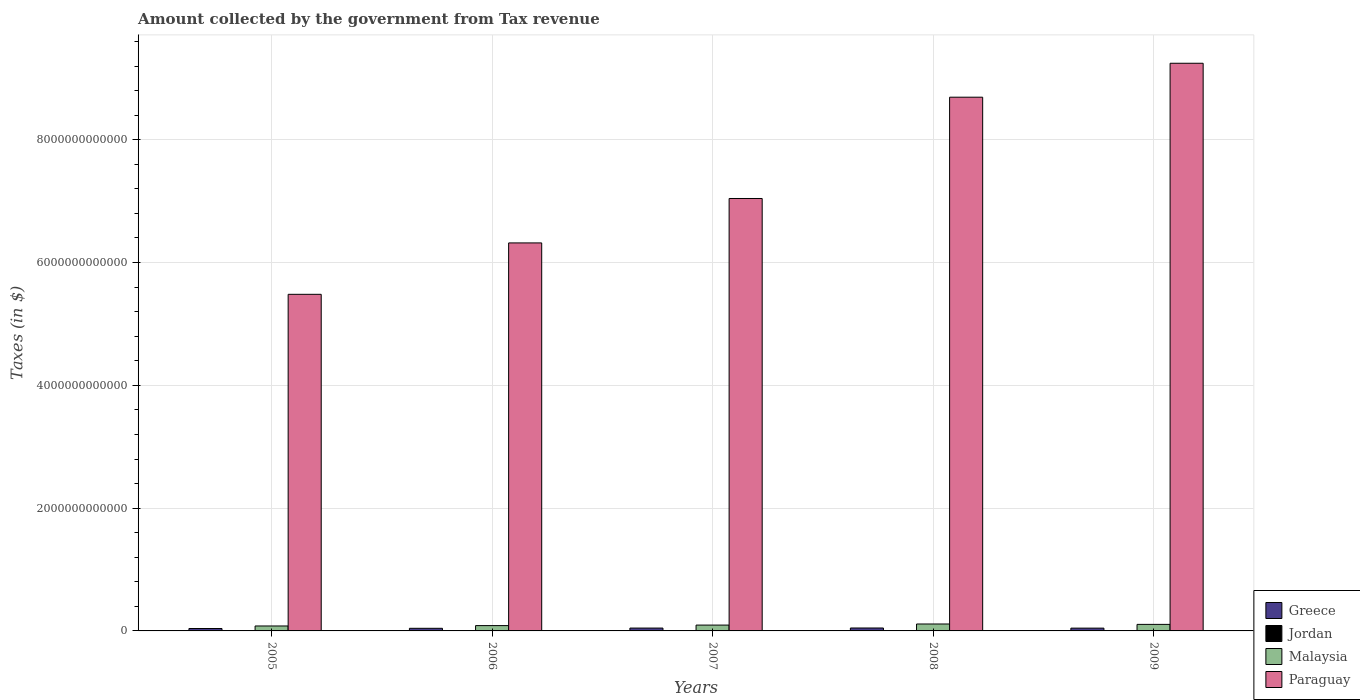How many different coloured bars are there?
Ensure brevity in your answer.  4. How many groups of bars are there?
Keep it short and to the point. 5. Are the number of bars on each tick of the X-axis equal?
Offer a terse response. Yes. How many bars are there on the 4th tick from the left?
Provide a short and direct response. 4. In how many cases, is the number of bars for a given year not equal to the number of legend labels?
Your response must be concise. 0. What is the amount collected by the government from tax revenue in Jordan in 2009?
Offer a very short reply. 2.88e+09. Across all years, what is the maximum amount collected by the government from tax revenue in Greece?
Your answer should be very brief. 4.77e+1. Across all years, what is the minimum amount collected by the government from tax revenue in Paraguay?
Your answer should be very brief. 5.48e+12. What is the total amount collected by the government from tax revenue in Malaysia in the graph?
Your answer should be compact. 4.82e+11. What is the difference between the amount collected by the government from tax revenue in Malaysia in 2005 and that in 2007?
Your response must be concise. -1.46e+1. What is the difference between the amount collected by the government from tax revenue in Jordan in 2007 and the amount collected by the government from tax revenue in Greece in 2005?
Your answer should be compact. -3.63e+1. What is the average amount collected by the government from tax revenue in Jordan per year?
Ensure brevity in your answer.  2.69e+09. In the year 2009, what is the difference between the amount collected by the government from tax revenue in Paraguay and amount collected by the government from tax revenue in Jordan?
Give a very brief answer. 9.24e+12. What is the ratio of the amount collected by the government from tax revenue in Paraguay in 2005 to that in 2006?
Your answer should be very brief. 0.87. Is the amount collected by the government from tax revenue in Paraguay in 2006 less than that in 2009?
Offer a very short reply. Yes. Is the difference between the amount collected by the government from tax revenue in Paraguay in 2005 and 2007 greater than the difference between the amount collected by the government from tax revenue in Jordan in 2005 and 2007?
Offer a terse response. No. What is the difference between the highest and the second highest amount collected by the government from tax revenue in Paraguay?
Your answer should be very brief. 5.53e+11. What is the difference between the highest and the lowest amount collected by the government from tax revenue in Greece?
Offer a very short reply. 8.40e+09. In how many years, is the amount collected by the government from tax revenue in Greece greater than the average amount collected by the government from tax revenue in Greece taken over all years?
Provide a succinct answer. 3. Is the sum of the amount collected by the government from tax revenue in Malaysia in 2005 and 2008 greater than the maximum amount collected by the government from tax revenue in Jordan across all years?
Make the answer very short. Yes. Is it the case that in every year, the sum of the amount collected by the government from tax revenue in Jordan and amount collected by the government from tax revenue in Paraguay is greater than the sum of amount collected by the government from tax revenue in Malaysia and amount collected by the government from tax revenue in Greece?
Give a very brief answer. Yes. What does the 3rd bar from the left in 2008 represents?
Give a very brief answer. Malaysia. What does the 1st bar from the right in 2009 represents?
Keep it short and to the point. Paraguay. Is it the case that in every year, the sum of the amount collected by the government from tax revenue in Malaysia and amount collected by the government from tax revenue in Jordan is greater than the amount collected by the government from tax revenue in Paraguay?
Your response must be concise. No. How many bars are there?
Give a very brief answer. 20. What is the difference between two consecutive major ticks on the Y-axis?
Provide a short and direct response. 2.00e+12. Where does the legend appear in the graph?
Make the answer very short. Bottom right. How many legend labels are there?
Give a very brief answer. 4. How are the legend labels stacked?
Give a very brief answer. Vertical. What is the title of the graph?
Give a very brief answer. Amount collected by the government from Tax revenue. What is the label or title of the Y-axis?
Your answer should be compact. Taxes (in $). What is the Taxes (in $) in Greece in 2005?
Provide a short and direct response. 3.93e+1. What is the Taxes (in $) of Jordan in 2005?
Make the answer very short. 2.18e+09. What is the Taxes (in $) in Malaysia in 2005?
Provide a short and direct response. 8.06e+1. What is the Taxes (in $) in Paraguay in 2005?
Offer a very short reply. 5.48e+12. What is the Taxes (in $) in Greece in 2006?
Offer a terse response. 4.27e+1. What is the Taxes (in $) of Jordan in 2006?
Your answer should be compact. 2.62e+09. What is the Taxes (in $) in Malaysia in 2006?
Your answer should be very brief. 8.66e+1. What is the Taxes (in $) in Paraguay in 2006?
Your response must be concise. 6.32e+12. What is the Taxes (in $) of Greece in 2007?
Provide a succinct answer. 4.64e+1. What is the Taxes (in $) in Jordan in 2007?
Give a very brief answer. 3.00e+09. What is the Taxes (in $) in Malaysia in 2007?
Your answer should be very brief. 9.52e+1. What is the Taxes (in $) of Paraguay in 2007?
Give a very brief answer. 7.04e+12. What is the Taxes (in $) of Greece in 2008?
Provide a succinct answer. 4.77e+1. What is the Taxes (in $) of Jordan in 2008?
Offer a terse response. 2.76e+09. What is the Taxes (in $) of Malaysia in 2008?
Provide a succinct answer. 1.13e+11. What is the Taxes (in $) of Paraguay in 2008?
Your answer should be very brief. 8.69e+12. What is the Taxes (in $) of Greece in 2009?
Ensure brevity in your answer.  4.53e+1. What is the Taxes (in $) of Jordan in 2009?
Provide a succinct answer. 2.88e+09. What is the Taxes (in $) of Malaysia in 2009?
Keep it short and to the point. 1.07e+11. What is the Taxes (in $) of Paraguay in 2009?
Your answer should be very brief. 9.25e+12. Across all years, what is the maximum Taxes (in $) of Greece?
Give a very brief answer. 4.77e+1. Across all years, what is the maximum Taxes (in $) in Jordan?
Give a very brief answer. 3.00e+09. Across all years, what is the maximum Taxes (in $) of Malaysia?
Your answer should be compact. 1.13e+11. Across all years, what is the maximum Taxes (in $) of Paraguay?
Your answer should be very brief. 9.25e+12. Across all years, what is the minimum Taxes (in $) in Greece?
Provide a short and direct response. 3.93e+1. Across all years, what is the minimum Taxes (in $) in Jordan?
Give a very brief answer. 2.18e+09. Across all years, what is the minimum Taxes (in $) of Malaysia?
Keep it short and to the point. 8.06e+1. Across all years, what is the minimum Taxes (in $) of Paraguay?
Ensure brevity in your answer.  5.48e+12. What is the total Taxes (in $) in Greece in the graph?
Offer a terse response. 2.21e+11. What is the total Taxes (in $) in Jordan in the graph?
Ensure brevity in your answer.  1.34e+1. What is the total Taxes (in $) of Malaysia in the graph?
Make the answer very short. 4.82e+11. What is the total Taxes (in $) in Paraguay in the graph?
Provide a succinct answer. 3.68e+13. What is the difference between the Taxes (in $) of Greece in 2005 and that in 2006?
Your answer should be compact. -3.47e+09. What is the difference between the Taxes (in $) of Jordan in 2005 and that in 2006?
Offer a terse response. -4.42e+08. What is the difference between the Taxes (in $) of Malaysia in 2005 and that in 2006?
Make the answer very short. -6.04e+09. What is the difference between the Taxes (in $) in Paraguay in 2005 and that in 2006?
Provide a succinct answer. -8.37e+11. What is the difference between the Taxes (in $) in Greece in 2005 and that in 2007?
Provide a short and direct response. -7.13e+09. What is the difference between the Taxes (in $) of Jordan in 2005 and that in 2007?
Your response must be concise. -8.16e+08. What is the difference between the Taxes (in $) in Malaysia in 2005 and that in 2007?
Make the answer very short. -1.46e+1. What is the difference between the Taxes (in $) in Paraguay in 2005 and that in 2007?
Your answer should be compact. -1.56e+12. What is the difference between the Taxes (in $) in Greece in 2005 and that in 2008?
Make the answer very short. -8.40e+09. What is the difference between the Taxes (in $) in Jordan in 2005 and that in 2008?
Ensure brevity in your answer.  -5.79e+08. What is the difference between the Taxes (in $) in Malaysia in 2005 and that in 2008?
Your response must be concise. -3.23e+1. What is the difference between the Taxes (in $) of Paraguay in 2005 and that in 2008?
Give a very brief answer. -3.21e+12. What is the difference between the Taxes (in $) of Greece in 2005 and that in 2009?
Make the answer very short. -6.06e+09. What is the difference between the Taxes (in $) in Jordan in 2005 and that in 2009?
Your answer should be compact. -7.01e+08. What is the difference between the Taxes (in $) of Malaysia in 2005 and that in 2009?
Provide a succinct answer. -2.59e+1. What is the difference between the Taxes (in $) of Paraguay in 2005 and that in 2009?
Your answer should be very brief. -3.76e+12. What is the difference between the Taxes (in $) in Greece in 2006 and that in 2007?
Provide a short and direct response. -3.66e+09. What is the difference between the Taxes (in $) in Jordan in 2006 and that in 2007?
Give a very brief answer. -3.74e+08. What is the difference between the Taxes (in $) in Malaysia in 2006 and that in 2007?
Make the answer very short. -8.54e+09. What is the difference between the Taxes (in $) in Paraguay in 2006 and that in 2007?
Offer a very short reply. -7.24e+11. What is the difference between the Taxes (in $) in Greece in 2006 and that in 2008?
Offer a very short reply. -4.93e+09. What is the difference between the Taxes (in $) of Jordan in 2006 and that in 2008?
Make the answer very short. -1.37e+08. What is the difference between the Taxes (in $) of Malaysia in 2006 and that in 2008?
Offer a terse response. -2.63e+1. What is the difference between the Taxes (in $) of Paraguay in 2006 and that in 2008?
Offer a terse response. -2.37e+12. What is the difference between the Taxes (in $) of Greece in 2006 and that in 2009?
Make the answer very short. -2.59e+09. What is the difference between the Taxes (in $) of Jordan in 2006 and that in 2009?
Give a very brief answer. -2.59e+08. What is the difference between the Taxes (in $) of Malaysia in 2006 and that in 2009?
Your answer should be very brief. -1.99e+1. What is the difference between the Taxes (in $) of Paraguay in 2006 and that in 2009?
Your answer should be compact. -2.93e+12. What is the difference between the Taxes (in $) in Greece in 2007 and that in 2008?
Offer a terse response. -1.28e+09. What is the difference between the Taxes (in $) in Jordan in 2007 and that in 2008?
Offer a very short reply. 2.37e+08. What is the difference between the Taxes (in $) of Malaysia in 2007 and that in 2008?
Your answer should be very brief. -1.77e+1. What is the difference between the Taxes (in $) of Paraguay in 2007 and that in 2008?
Make the answer very short. -1.65e+12. What is the difference between the Taxes (in $) of Greece in 2007 and that in 2009?
Your response must be concise. 1.07e+09. What is the difference between the Taxes (in $) in Jordan in 2007 and that in 2009?
Ensure brevity in your answer.  1.15e+08. What is the difference between the Taxes (in $) of Malaysia in 2007 and that in 2009?
Offer a terse response. -1.13e+1. What is the difference between the Taxes (in $) of Paraguay in 2007 and that in 2009?
Your answer should be compact. -2.20e+12. What is the difference between the Taxes (in $) in Greece in 2008 and that in 2009?
Your answer should be very brief. 2.34e+09. What is the difference between the Taxes (in $) in Jordan in 2008 and that in 2009?
Provide a short and direct response. -1.22e+08. What is the difference between the Taxes (in $) in Malaysia in 2008 and that in 2009?
Your response must be concise. 6.39e+09. What is the difference between the Taxes (in $) in Paraguay in 2008 and that in 2009?
Provide a short and direct response. -5.53e+11. What is the difference between the Taxes (in $) of Greece in 2005 and the Taxes (in $) of Jordan in 2006?
Provide a short and direct response. 3.66e+1. What is the difference between the Taxes (in $) in Greece in 2005 and the Taxes (in $) in Malaysia in 2006?
Keep it short and to the point. -4.74e+1. What is the difference between the Taxes (in $) in Greece in 2005 and the Taxes (in $) in Paraguay in 2006?
Provide a short and direct response. -6.28e+12. What is the difference between the Taxes (in $) in Jordan in 2005 and the Taxes (in $) in Malaysia in 2006?
Make the answer very short. -8.45e+1. What is the difference between the Taxes (in $) in Jordan in 2005 and the Taxes (in $) in Paraguay in 2006?
Ensure brevity in your answer.  -6.32e+12. What is the difference between the Taxes (in $) of Malaysia in 2005 and the Taxes (in $) of Paraguay in 2006?
Your answer should be compact. -6.24e+12. What is the difference between the Taxes (in $) in Greece in 2005 and the Taxes (in $) in Jordan in 2007?
Offer a very short reply. 3.63e+1. What is the difference between the Taxes (in $) of Greece in 2005 and the Taxes (in $) of Malaysia in 2007?
Keep it short and to the point. -5.59e+1. What is the difference between the Taxes (in $) in Greece in 2005 and the Taxes (in $) in Paraguay in 2007?
Keep it short and to the point. -7.00e+12. What is the difference between the Taxes (in $) in Jordan in 2005 and the Taxes (in $) in Malaysia in 2007?
Give a very brief answer. -9.30e+1. What is the difference between the Taxes (in $) of Jordan in 2005 and the Taxes (in $) of Paraguay in 2007?
Your answer should be compact. -7.04e+12. What is the difference between the Taxes (in $) in Malaysia in 2005 and the Taxes (in $) in Paraguay in 2007?
Offer a very short reply. -6.96e+12. What is the difference between the Taxes (in $) of Greece in 2005 and the Taxes (in $) of Jordan in 2008?
Offer a very short reply. 3.65e+1. What is the difference between the Taxes (in $) of Greece in 2005 and the Taxes (in $) of Malaysia in 2008?
Your response must be concise. -7.36e+1. What is the difference between the Taxes (in $) of Greece in 2005 and the Taxes (in $) of Paraguay in 2008?
Your answer should be very brief. -8.65e+12. What is the difference between the Taxes (in $) of Jordan in 2005 and the Taxes (in $) of Malaysia in 2008?
Make the answer very short. -1.11e+11. What is the difference between the Taxes (in $) of Jordan in 2005 and the Taxes (in $) of Paraguay in 2008?
Your answer should be compact. -8.69e+12. What is the difference between the Taxes (in $) in Malaysia in 2005 and the Taxes (in $) in Paraguay in 2008?
Make the answer very short. -8.61e+12. What is the difference between the Taxes (in $) in Greece in 2005 and the Taxes (in $) in Jordan in 2009?
Your answer should be compact. 3.64e+1. What is the difference between the Taxes (in $) of Greece in 2005 and the Taxes (in $) of Malaysia in 2009?
Your response must be concise. -6.72e+1. What is the difference between the Taxes (in $) in Greece in 2005 and the Taxes (in $) in Paraguay in 2009?
Provide a short and direct response. -9.21e+12. What is the difference between the Taxes (in $) of Jordan in 2005 and the Taxes (in $) of Malaysia in 2009?
Offer a terse response. -1.04e+11. What is the difference between the Taxes (in $) of Jordan in 2005 and the Taxes (in $) of Paraguay in 2009?
Offer a very short reply. -9.24e+12. What is the difference between the Taxes (in $) of Malaysia in 2005 and the Taxes (in $) of Paraguay in 2009?
Keep it short and to the point. -9.17e+12. What is the difference between the Taxes (in $) in Greece in 2006 and the Taxes (in $) in Jordan in 2007?
Ensure brevity in your answer.  3.97e+1. What is the difference between the Taxes (in $) of Greece in 2006 and the Taxes (in $) of Malaysia in 2007?
Provide a short and direct response. -5.24e+1. What is the difference between the Taxes (in $) in Greece in 2006 and the Taxes (in $) in Paraguay in 2007?
Your response must be concise. -7.00e+12. What is the difference between the Taxes (in $) of Jordan in 2006 and the Taxes (in $) of Malaysia in 2007?
Your answer should be very brief. -9.25e+1. What is the difference between the Taxes (in $) in Jordan in 2006 and the Taxes (in $) in Paraguay in 2007?
Provide a succinct answer. -7.04e+12. What is the difference between the Taxes (in $) of Malaysia in 2006 and the Taxes (in $) of Paraguay in 2007?
Your answer should be compact. -6.96e+12. What is the difference between the Taxes (in $) in Greece in 2006 and the Taxes (in $) in Jordan in 2008?
Provide a short and direct response. 4.00e+1. What is the difference between the Taxes (in $) of Greece in 2006 and the Taxes (in $) of Malaysia in 2008?
Offer a very short reply. -7.02e+1. What is the difference between the Taxes (in $) of Greece in 2006 and the Taxes (in $) of Paraguay in 2008?
Your answer should be compact. -8.65e+12. What is the difference between the Taxes (in $) in Jordan in 2006 and the Taxes (in $) in Malaysia in 2008?
Your response must be concise. -1.10e+11. What is the difference between the Taxes (in $) in Jordan in 2006 and the Taxes (in $) in Paraguay in 2008?
Your response must be concise. -8.69e+12. What is the difference between the Taxes (in $) in Malaysia in 2006 and the Taxes (in $) in Paraguay in 2008?
Offer a terse response. -8.61e+12. What is the difference between the Taxes (in $) in Greece in 2006 and the Taxes (in $) in Jordan in 2009?
Your answer should be very brief. 3.99e+1. What is the difference between the Taxes (in $) of Greece in 2006 and the Taxes (in $) of Malaysia in 2009?
Give a very brief answer. -6.38e+1. What is the difference between the Taxes (in $) of Greece in 2006 and the Taxes (in $) of Paraguay in 2009?
Offer a terse response. -9.20e+12. What is the difference between the Taxes (in $) of Jordan in 2006 and the Taxes (in $) of Malaysia in 2009?
Make the answer very short. -1.04e+11. What is the difference between the Taxes (in $) of Jordan in 2006 and the Taxes (in $) of Paraguay in 2009?
Give a very brief answer. -9.24e+12. What is the difference between the Taxes (in $) of Malaysia in 2006 and the Taxes (in $) of Paraguay in 2009?
Offer a very short reply. -9.16e+12. What is the difference between the Taxes (in $) in Greece in 2007 and the Taxes (in $) in Jordan in 2008?
Make the answer very short. 4.36e+1. What is the difference between the Taxes (in $) of Greece in 2007 and the Taxes (in $) of Malaysia in 2008?
Your response must be concise. -6.65e+1. What is the difference between the Taxes (in $) in Greece in 2007 and the Taxes (in $) in Paraguay in 2008?
Give a very brief answer. -8.65e+12. What is the difference between the Taxes (in $) of Jordan in 2007 and the Taxes (in $) of Malaysia in 2008?
Your answer should be very brief. -1.10e+11. What is the difference between the Taxes (in $) in Jordan in 2007 and the Taxes (in $) in Paraguay in 2008?
Your response must be concise. -8.69e+12. What is the difference between the Taxes (in $) of Malaysia in 2007 and the Taxes (in $) of Paraguay in 2008?
Your answer should be compact. -8.60e+12. What is the difference between the Taxes (in $) of Greece in 2007 and the Taxes (in $) of Jordan in 2009?
Ensure brevity in your answer.  4.35e+1. What is the difference between the Taxes (in $) of Greece in 2007 and the Taxes (in $) of Malaysia in 2009?
Ensure brevity in your answer.  -6.01e+1. What is the difference between the Taxes (in $) in Greece in 2007 and the Taxes (in $) in Paraguay in 2009?
Give a very brief answer. -9.20e+12. What is the difference between the Taxes (in $) of Jordan in 2007 and the Taxes (in $) of Malaysia in 2009?
Provide a succinct answer. -1.04e+11. What is the difference between the Taxes (in $) of Jordan in 2007 and the Taxes (in $) of Paraguay in 2009?
Your response must be concise. -9.24e+12. What is the difference between the Taxes (in $) of Malaysia in 2007 and the Taxes (in $) of Paraguay in 2009?
Keep it short and to the point. -9.15e+12. What is the difference between the Taxes (in $) of Greece in 2008 and the Taxes (in $) of Jordan in 2009?
Your answer should be very brief. 4.48e+1. What is the difference between the Taxes (in $) in Greece in 2008 and the Taxes (in $) in Malaysia in 2009?
Your response must be concise. -5.88e+1. What is the difference between the Taxes (in $) in Greece in 2008 and the Taxes (in $) in Paraguay in 2009?
Keep it short and to the point. -9.20e+12. What is the difference between the Taxes (in $) in Jordan in 2008 and the Taxes (in $) in Malaysia in 2009?
Provide a succinct answer. -1.04e+11. What is the difference between the Taxes (in $) in Jordan in 2008 and the Taxes (in $) in Paraguay in 2009?
Ensure brevity in your answer.  -9.24e+12. What is the difference between the Taxes (in $) in Malaysia in 2008 and the Taxes (in $) in Paraguay in 2009?
Provide a short and direct response. -9.13e+12. What is the average Taxes (in $) in Greece per year?
Your response must be concise. 4.43e+1. What is the average Taxes (in $) in Jordan per year?
Provide a succinct answer. 2.69e+09. What is the average Taxes (in $) in Malaysia per year?
Offer a terse response. 9.64e+1. What is the average Taxes (in $) of Paraguay per year?
Provide a succinct answer. 7.36e+12. In the year 2005, what is the difference between the Taxes (in $) of Greece and Taxes (in $) of Jordan?
Provide a succinct answer. 3.71e+1. In the year 2005, what is the difference between the Taxes (in $) in Greece and Taxes (in $) in Malaysia?
Make the answer very short. -4.13e+1. In the year 2005, what is the difference between the Taxes (in $) of Greece and Taxes (in $) of Paraguay?
Provide a short and direct response. -5.44e+12. In the year 2005, what is the difference between the Taxes (in $) in Jordan and Taxes (in $) in Malaysia?
Provide a short and direct response. -7.84e+1. In the year 2005, what is the difference between the Taxes (in $) of Jordan and Taxes (in $) of Paraguay?
Give a very brief answer. -5.48e+12. In the year 2005, what is the difference between the Taxes (in $) of Malaysia and Taxes (in $) of Paraguay?
Your answer should be very brief. -5.40e+12. In the year 2006, what is the difference between the Taxes (in $) in Greece and Taxes (in $) in Jordan?
Your answer should be compact. 4.01e+1. In the year 2006, what is the difference between the Taxes (in $) in Greece and Taxes (in $) in Malaysia?
Make the answer very short. -4.39e+1. In the year 2006, what is the difference between the Taxes (in $) of Greece and Taxes (in $) of Paraguay?
Provide a short and direct response. -6.28e+12. In the year 2006, what is the difference between the Taxes (in $) in Jordan and Taxes (in $) in Malaysia?
Offer a terse response. -8.40e+1. In the year 2006, what is the difference between the Taxes (in $) in Jordan and Taxes (in $) in Paraguay?
Your answer should be compact. -6.32e+12. In the year 2006, what is the difference between the Taxes (in $) in Malaysia and Taxes (in $) in Paraguay?
Make the answer very short. -6.23e+12. In the year 2007, what is the difference between the Taxes (in $) of Greece and Taxes (in $) of Jordan?
Offer a very short reply. 4.34e+1. In the year 2007, what is the difference between the Taxes (in $) in Greece and Taxes (in $) in Malaysia?
Ensure brevity in your answer.  -4.88e+1. In the year 2007, what is the difference between the Taxes (in $) in Greece and Taxes (in $) in Paraguay?
Offer a very short reply. -7.00e+12. In the year 2007, what is the difference between the Taxes (in $) of Jordan and Taxes (in $) of Malaysia?
Give a very brief answer. -9.22e+1. In the year 2007, what is the difference between the Taxes (in $) of Jordan and Taxes (in $) of Paraguay?
Your response must be concise. -7.04e+12. In the year 2007, what is the difference between the Taxes (in $) in Malaysia and Taxes (in $) in Paraguay?
Give a very brief answer. -6.95e+12. In the year 2008, what is the difference between the Taxes (in $) in Greece and Taxes (in $) in Jordan?
Ensure brevity in your answer.  4.49e+1. In the year 2008, what is the difference between the Taxes (in $) of Greece and Taxes (in $) of Malaysia?
Make the answer very short. -6.52e+1. In the year 2008, what is the difference between the Taxes (in $) of Greece and Taxes (in $) of Paraguay?
Make the answer very short. -8.65e+12. In the year 2008, what is the difference between the Taxes (in $) of Jordan and Taxes (in $) of Malaysia?
Your answer should be compact. -1.10e+11. In the year 2008, what is the difference between the Taxes (in $) of Jordan and Taxes (in $) of Paraguay?
Offer a very short reply. -8.69e+12. In the year 2008, what is the difference between the Taxes (in $) in Malaysia and Taxes (in $) in Paraguay?
Provide a short and direct response. -8.58e+12. In the year 2009, what is the difference between the Taxes (in $) of Greece and Taxes (in $) of Jordan?
Your answer should be very brief. 4.24e+1. In the year 2009, what is the difference between the Taxes (in $) in Greece and Taxes (in $) in Malaysia?
Your response must be concise. -6.12e+1. In the year 2009, what is the difference between the Taxes (in $) in Greece and Taxes (in $) in Paraguay?
Give a very brief answer. -9.20e+12. In the year 2009, what is the difference between the Taxes (in $) in Jordan and Taxes (in $) in Malaysia?
Your answer should be compact. -1.04e+11. In the year 2009, what is the difference between the Taxes (in $) of Jordan and Taxes (in $) of Paraguay?
Offer a very short reply. -9.24e+12. In the year 2009, what is the difference between the Taxes (in $) in Malaysia and Taxes (in $) in Paraguay?
Your answer should be compact. -9.14e+12. What is the ratio of the Taxes (in $) in Greece in 2005 to that in 2006?
Keep it short and to the point. 0.92. What is the ratio of the Taxes (in $) of Jordan in 2005 to that in 2006?
Make the answer very short. 0.83. What is the ratio of the Taxes (in $) in Malaysia in 2005 to that in 2006?
Your response must be concise. 0.93. What is the ratio of the Taxes (in $) in Paraguay in 2005 to that in 2006?
Your answer should be compact. 0.87. What is the ratio of the Taxes (in $) in Greece in 2005 to that in 2007?
Your answer should be very brief. 0.85. What is the ratio of the Taxes (in $) in Jordan in 2005 to that in 2007?
Provide a short and direct response. 0.73. What is the ratio of the Taxes (in $) in Malaysia in 2005 to that in 2007?
Provide a succinct answer. 0.85. What is the ratio of the Taxes (in $) of Paraguay in 2005 to that in 2007?
Ensure brevity in your answer.  0.78. What is the ratio of the Taxes (in $) of Greece in 2005 to that in 2008?
Ensure brevity in your answer.  0.82. What is the ratio of the Taxes (in $) of Jordan in 2005 to that in 2008?
Provide a short and direct response. 0.79. What is the ratio of the Taxes (in $) of Malaysia in 2005 to that in 2008?
Make the answer very short. 0.71. What is the ratio of the Taxes (in $) in Paraguay in 2005 to that in 2008?
Your response must be concise. 0.63. What is the ratio of the Taxes (in $) of Greece in 2005 to that in 2009?
Offer a terse response. 0.87. What is the ratio of the Taxes (in $) in Jordan in 2005 to that in 2009?
Offer a very short reply. 0.76. What is the ratio of the Taxes (in $) of Malaysia in 2005 to that in 2009?
Give a very brief answer. 0.76. What is the ratio of the Taxes (in $) in Paraguay in 2005 to that in 2009?
Your answer should be very brief. 0.59. What is the ratio of the Taxes (in $) in Greece in 2006 to that in 2007?
Provide a short and direct response. 0.92. What is the ratio of the Taxes (in $) of Jordan in 2006 to that in 2007?
Ensure brevity in your answer.  0.88. What is the ratio of the Taxes (in $) in Malaysia in 2006 to that in 2007?
Ensure brevity in your answer.  0.91. What is the ratio of the Taxes (in $) of Paraguay in 2006 to that in 2007?
Provide a succinct answer. 0.9. What is the ratio of the Taxes (in $) of Greece in 2006 to that in 2008?
Your answer should be compact. 0.9. What is the ratio of the Taxes (in $) in Jordan in 2006 to that in 2008?
Your response must be concise. 0.95. What is the ratio of the Taxes (in $) of Malaysia in 2006 to that in 2008?
Your answer should be compact. 0.77. What is the ratio of the Taxes (in $) of Paraguay in 2006 to that in 2008?
Provide a short and direct response. 0.73. What is the ratio of the Taxes (in $) in Greece in 2006 to that in 2009?
Make the answer very short. 0.94. What is the ratio of the Taxes (in $) in Jordan in 2006 to that in 2009?
Offer a very short reply. 0.91. What is the ratio of the Taxes (in $) in Malaysia in 2006 to that in 2009?
Provide a succinct answer. 0.81. What is the ratio of the Taxes (in $) in Paraguay in 2006 to that in 2009?
Ensure brevity in your answer.  0.68. What is the ratio of the Taxes (in $) in Greece in 2007 to that in 2008?
Provide a succinct answer. 0.97. What is the ratio of the Taxes (in $) in Jordan in 2007 to that in 2008?
Make the answer very short. 1.09. What is the ratio of the Taxes (in $) of Malaysia in 2007 to that in 2008?
Give a very brief answer. 0.84. What is the ratio of the Taxes (in $) in Paraguay in 2007 to that in 2008?
Offer a terse response. 0.81. What is the ratio of the Taxes (in $) of Greece in 2007 to that in 2009?
Offer a terse response. 1.02. What is the ratio of the Taxes (in $) in Malaysia in 2007 to that in 2009?
Provide a short and direct response. 0.89. What is the ratio of the Taxes (in $) in Paraguay in 2007 to that in 2009?
Provide a short and direct response. 0.76. What is the ratio of the Taxes (in $) in Greece in 2008 to that in 2009?
Provide a succinct answer. 1.05. What is the ratio of the Taxes (in $) of Jordan in 2008 to that in 2009?
Offer a very short reply. 0.96. What is the ratio of the Taxes (in $) in Malaysia in 2008 to that in 2009?
Your answer should be compact. 1.06. What is the ratio of the Taxes (in $) of Paraguay in 2008 to that in 2009?
Your answer should be compact. 0.94. What is the difference between the highest and the second highest Taxes (in $) of Greece?
Make the answer very short. 1.28e+09. What is the difference between the highest and the second highest Taxes (in $) of Jordan?
Offer a terse response. 1.15e+08. What is the difference between the highest and the second highest Taxes (in $) in Malaysia?
Your answer should be compact. 6.39e+09. What is the difference between the highest and the second highest Taxes (in $) of Paraguay?
Ensure brevity in your answer.  5.53e+11. What is the difference between the highest and the lowest Taxes (in $) of Greece?
Offer a very short reply. 8.40e+09. What is the difference between the highest and the lowest Taxes (in $) in Jordan?
Ensure brevity in your answer.  8.16e+08. What is the difference between the highest and the lowest Taxes (in $) in Malaysia?
Offer a very short reply. 3.23e+1. What is the difference between the highest and the lowest Taxes (in $) in Paraguay?
Make the answer very short. 3.76e+12. 